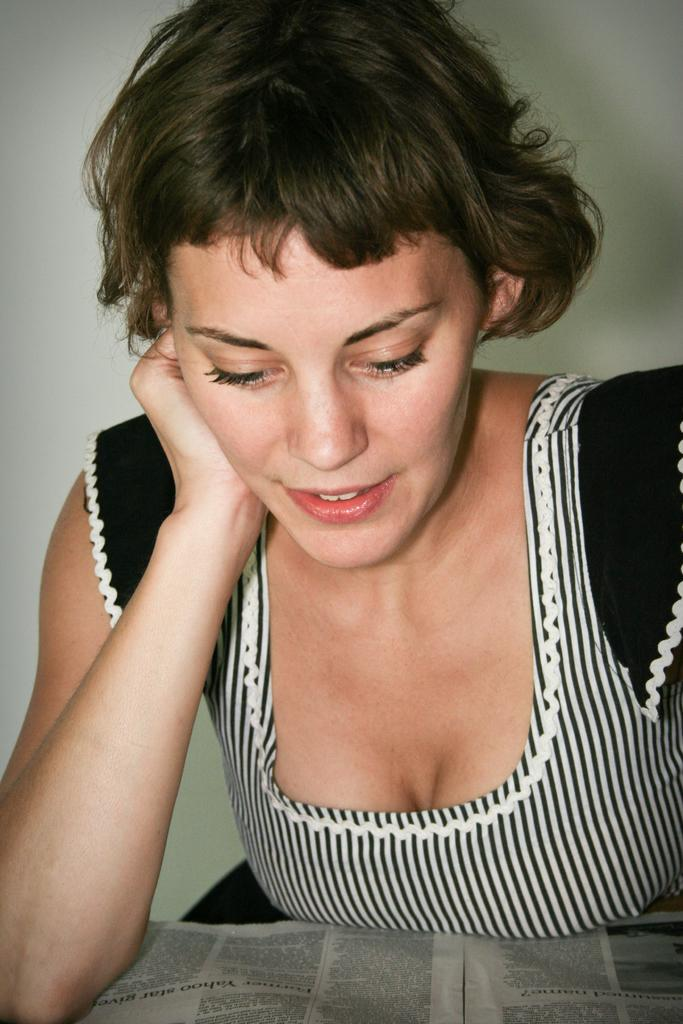Who is the main subject in the image? There is a woman in the image. What is the woman doing in the image? The woman is reading a newspaper. What object is present in the image that the woman might be using? There is a table in the image that the woman might be using to hold the newspaper. What type of nut can be seen on the moon in the image? There is no moon or nut present in the image; it features a woman reading a newspaper at a table. 